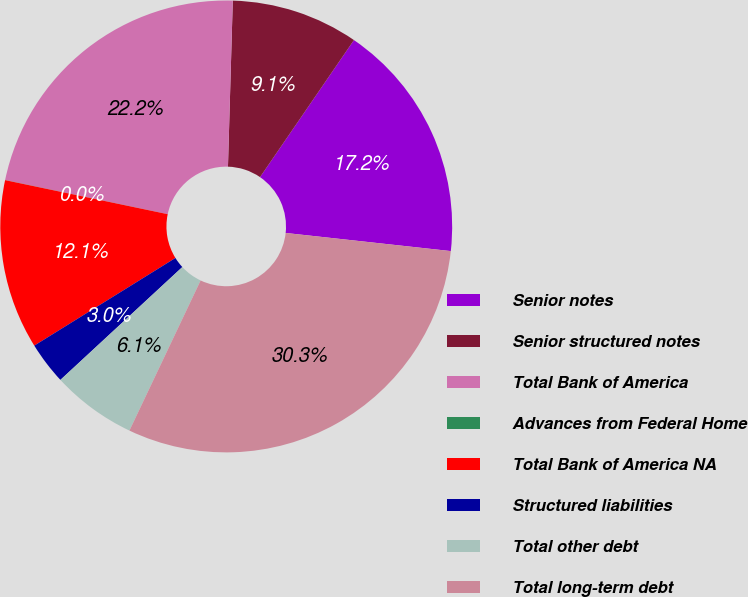<chart> <loc_0><loc_0><loc_500><loc_500><pie_chart><fcel>Senior notes<fcel>Senior structured notes<fcel>Total Bank of America<fcel>Advances from Federal Home<fcel>Total Bank of America NA<fcel>Structured liabilities<fcel>Total other debt<fcel>Total long-term debt<nl><fcel>17.18%<fcel>9.1%<fcel>22.17%<fcel>0.01%<fcel>12.13%<fcel>3.04%<fcel>6.07%<fcel>30.31%<nl></chart> 